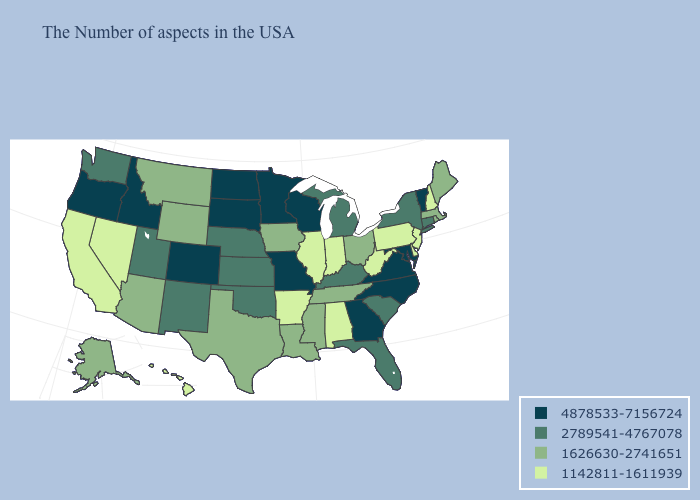Does North Dakota have the highest value in the MidWest?
Be succinct. Yes. Which states have the lowest value in the USA?
Keep it brief. New Hampshire, New Jersey, Delaware, Pennsylvania, West Virginia, Indiana, Alabama, Illinois, Arkansas, Nevada, California, Hawaii. Does Mississippi have the lowest value in the South?
Give a very brief answer. No. What is the value of Delaware?
Answer briefly. 1142811-1611939. What is the lowest value in the West?
Be succinct. 1142811-1611939. Does South Dakota have the highest value in the USA?
Short answer required. Yes. Does Rhode Island have the same value as Iowa?
Quick response, please. Yes. Which states have the lowest value in the Northeast?
Quick response, please. New Hampshire, New Jersey, Pennsylvania. What is the highest value in states that border Kansas?
Quick response, please. 4878533-7156724. Does Alabama have the lowest value in the South?
Keep it brief. Yes. What is the highest value in states that border Vermont?
Be succinct. 2789541-4767078. What is the value of Ohio?
Be succinct. 1626630-2741651. What is the highest value in the Northeast ?
Quick response, please. 4878533-7156724. Among the states that border Illinois , which have the lowest value?
Write a very short answer. Indiana. Name the states that have a value in the range 1142811-1611939?
Write a very short answer. New Hampshire, New Jersey, Delaware, Pennsylvania, West Virginia, Indiana, Alabama, Illinois, Arkansas, Nevada, California, Hawaii. 